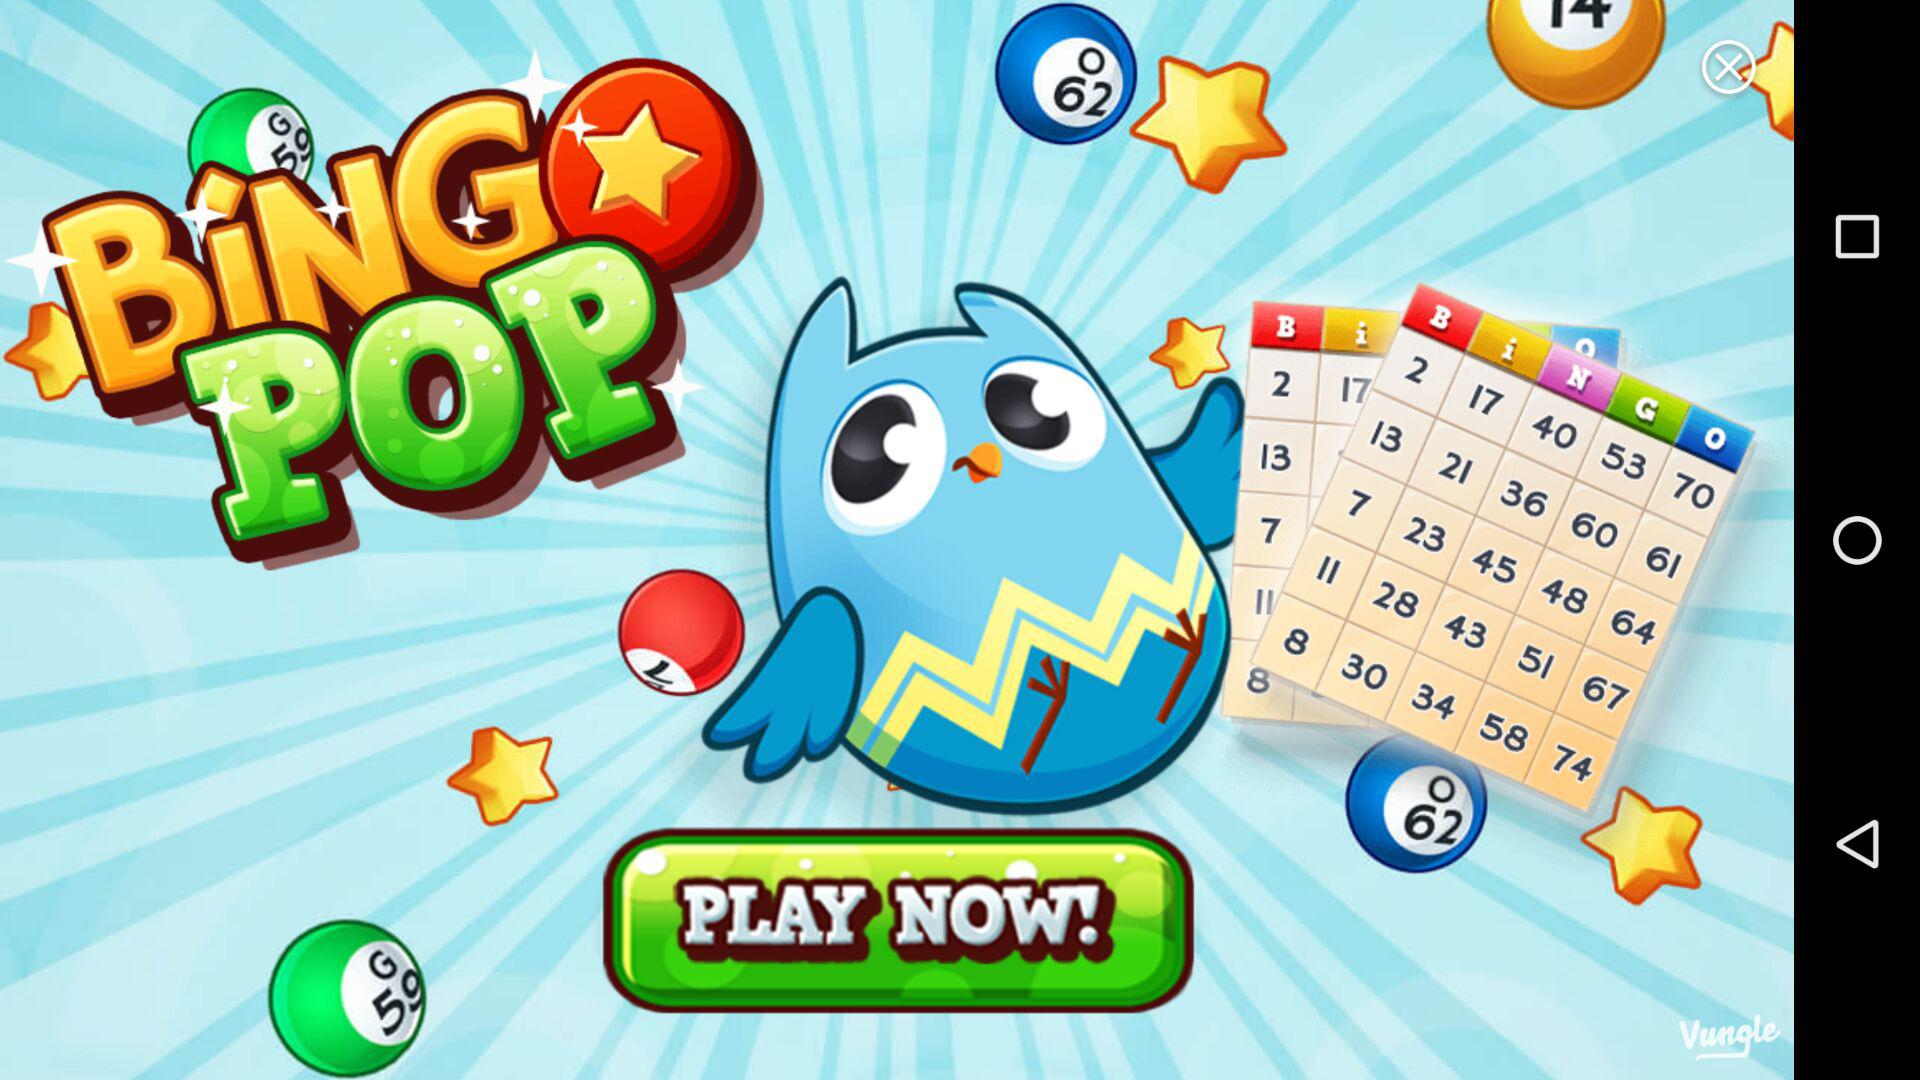What is the reward value for day two? The reward value for day two is 10. 